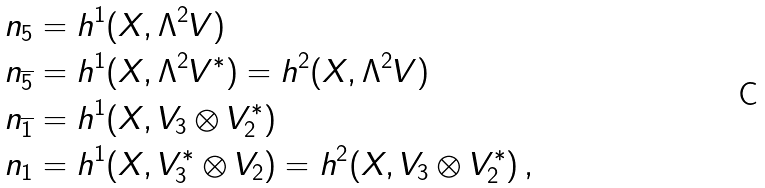Convert formula to latex. <formula><loc_0><loc_0><loc_500><loc_500>n _ { 5 } & = h ^ { 1 } ( X , \Lambda ^ { 2 } V ) \\ n _ { \overline { 5 } } & = h ^ { 1 } ( X , \Lambda ^ { 2 } V ^ { \ast } ) = h ^ { 2 } ( X , \Lambda ^ { 2 } V ) \\ n _ { \overline { 1 } } & = h ^ { 1 } ( X , V _ { 3 } \otimes V _ { 2 } ^ { * } ) \\ n _ { 1 } & = h ^ { 1 } ( X , V _ { 3 } ^ { * } \otimes V _ { 2 } ) = h ^ { 2 } ( X , V _ { 3 } \otimes V _ { 2 } ^ { * } ) \, ,</formula> 